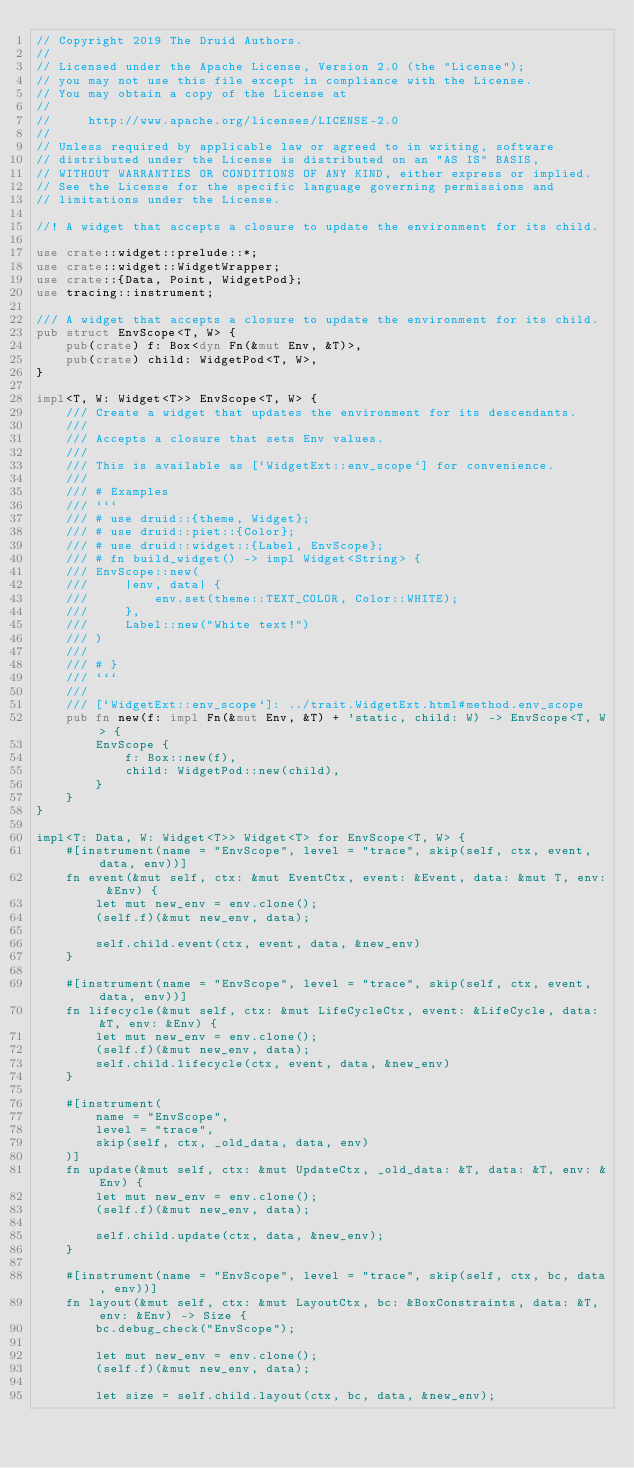Convert code to text. <code><loc_0><loc_0><loc_500><loc_500><_Rust_>// Copyright 2019 The Druid Authors.
//
// Licensed under the Apache License, Version 2.0 (the "License");
// you may not use this file except in compliance with the License.
// You may obtain a copy of the License at
//
//     http://www.apache.org/licenses/LICENSE-2.0
//
// Unless required by applicable law or agreed to in writing, software
// distributed under the License is distributed on an "AS IS" BASIS,
// WITHOUT WARRANTIES OR CONDITIONS OF ANY KIND, either express or implied.
// See the License for the specific language governing permissions and
// limitations under the License.

//! A widget that accepts a closure to update the environment for its child.

use crate::widget::prelude::*;
use crate::widget::WidgetWrapper;
use crate::{Data, Point, WidgetPod};
use tracing::instrument;

/// A widget that accepts a closure to update the environment for its child.
pub struct EnvScope<T, W> {
    pub(crate) f: Box<dyn Fn(&mut Env, &T)>,
    pub(crate) child: WidgetPod<T, W>,
}

impl<T, W: Widget<T>> EnvScope<T, W> {
    /// Create a widget that updates the environment for its descendants.
    ///
    /// Accepts a closure that sets Env values.
    ///
    /// This is available as [`WidgetExt::env_scope`] for convenience.
    ///
    /// # Examples
    /// ```
    /// # use druid::{theme, Widget};
    /// # use druid::piet::{Color};
    /// # use druid::widget::{Label, EnvScope};
    /// # fn build_widget() -> impl Widget<String> {
    /// EnvScope::new(
    ///     |env, data| {
    ///         env.set(theme::TEXT_COLOR, Color::WHITE);
    ///     },
    ///     Label::new("White text!")
    /// )
    ///
    /// # }
    /// ```
    ///
    /// [`WidgetExt::env_scope`]: ../trait.WidgetExt.html#method.env_scope
    pub fn new(f: impl Fn(&mut Env, &T) + 'static, child: W) -> EnvScope<T, W> {
        EnvScope {
            f: Box::new(f),
            child: WidgetPod::new(child),
        }
    }
}

impl<T: Data, W: Widget<T>> Widget<T> for EnvScope<T, W> {
    #[instrument(name = "EnvScope", level = "trace", skip(self, ctx, event, data, env))]
    fn event(&mut self, ctx: &mut EventCtx, event: &Event, data: &mut T, env: &Env) {
        let mut new_env = env.clone();
        (self.f)(&mut new_env, data);

        self.child.event(ctx, event, data, &new_env)
    }

    #[instrument(name = "EnvScope", level = "trace", skip(self, ctx, event, data, env))]
    fn lifecycle(&mut self, ctx: &mut LifeCycleCtx, event: &LifeCycle, data: &T, env: &Env) {
        let mut new_env = env.clone();
        (self.f)(&mut new_env, data);
        self.child.lifecycle(ctx, event, data, &new_env)
    }

    #[instrument(
        name = "EnvScope",
        level = "trace",
        skip(self, ctx, _old_data, data, env)
    )]
    fn update(&mut self, ctx: &mut UpdateCtx, _old_data: &T, data: &T, env: &Env) {
        let mut new_env = env.clone();
        (self.f)(&mut new_env, data);

        self.child.update(ctx, data, &new_env);
    }

    #[instrument(name = "EnvScope", level = "trace", skip(self, ctx, bc, data, env))]
    fn layout(&mut self, ctx: &mut LayoutCtx, bc: &BoxConstraints, data: &T, env: &Env) -> Size {
        bc.debug_check("EnvScope");

        let mut new_env = env.clone();
        (self.f)(&mut new_env, data);

        let size = self.child.layout(ctx, bc, data, &new_env);</code> 